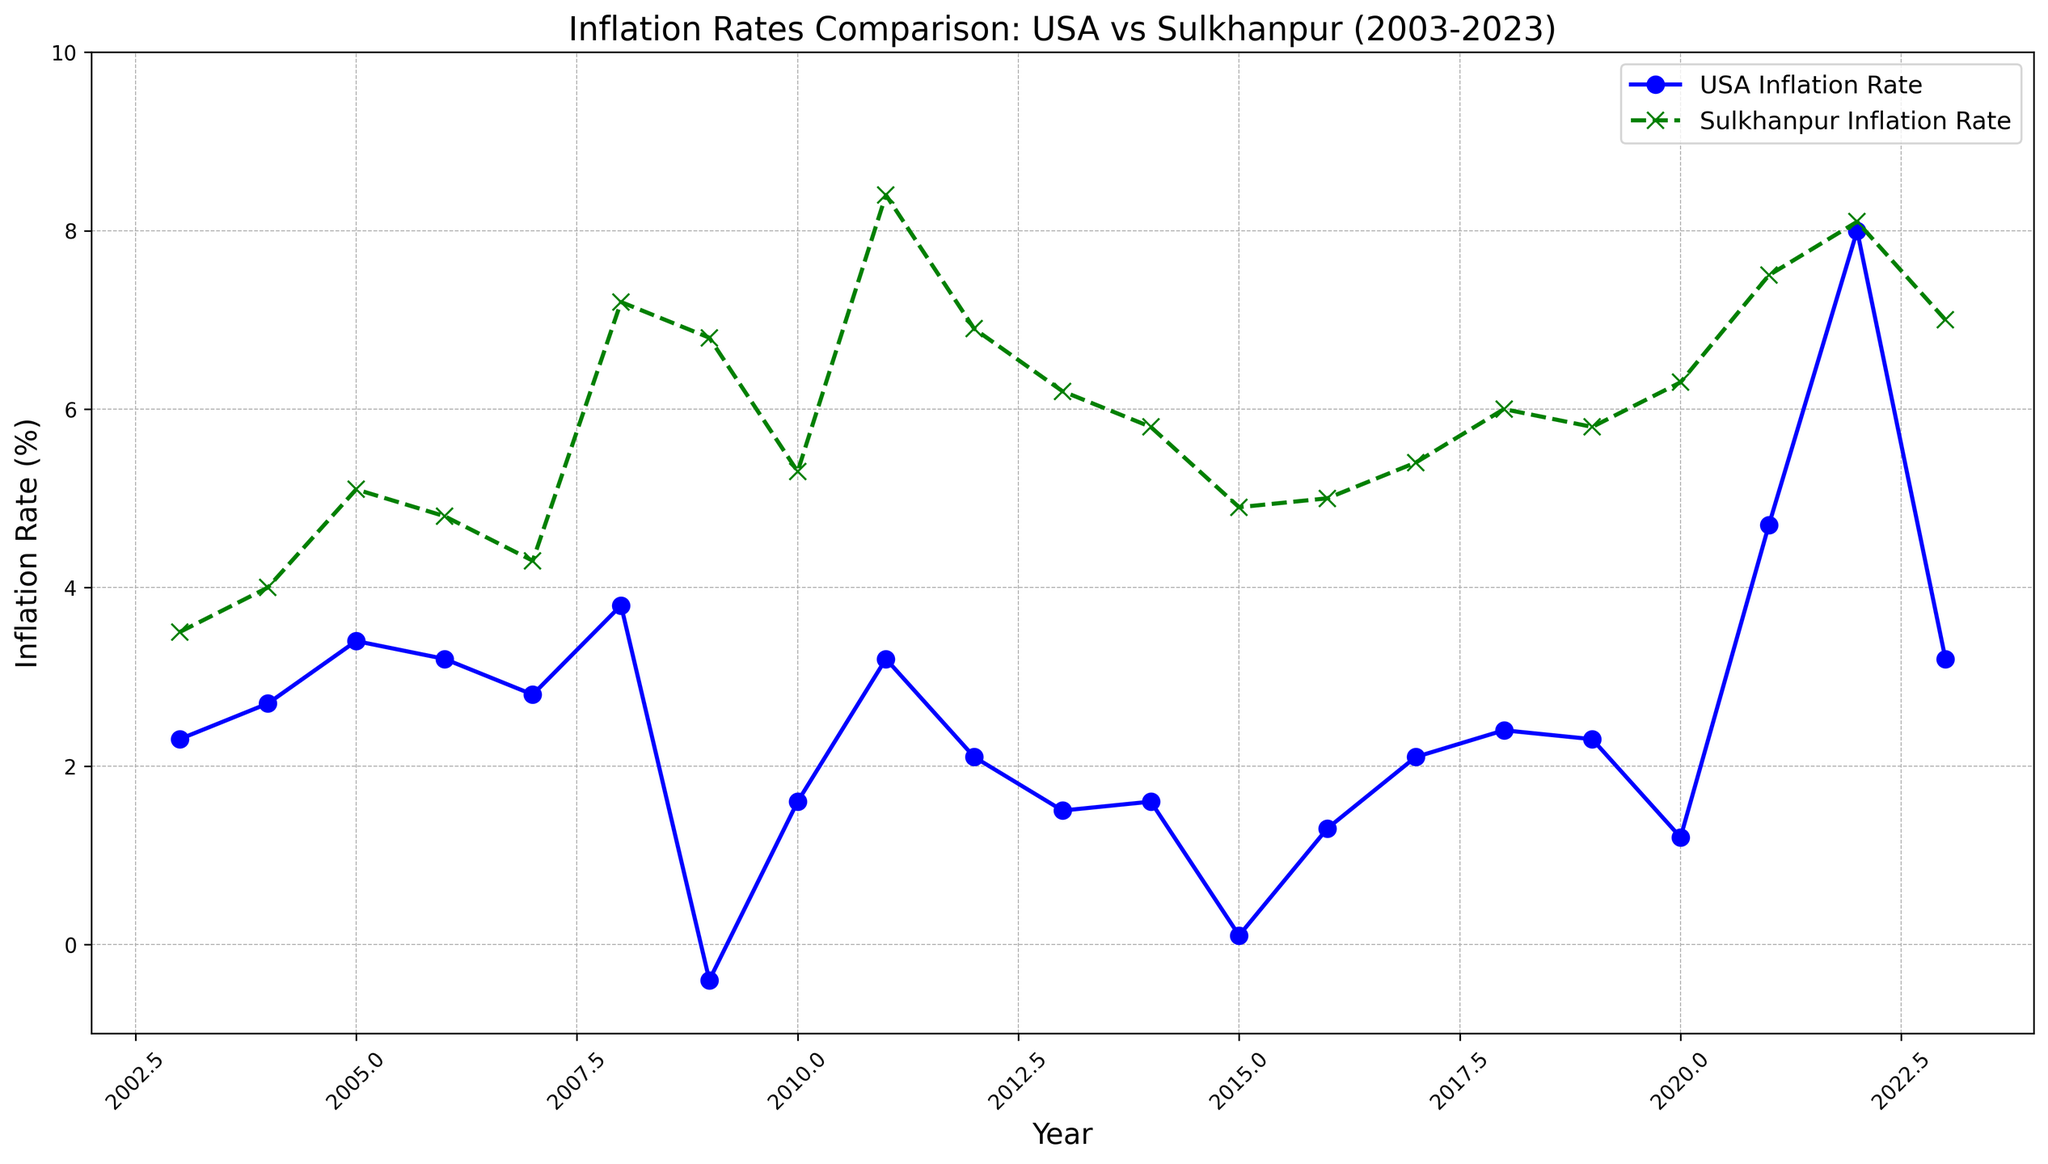Which year did Sulkhanpur experience the highest inflation rate? First, observe the green line representing Sulkhanpur's inflation rate. Identify the year where the line peaks, which is around 2011 with an inflation rate of 8.4%
Answer: 2011 When was the USA's inflation rate lowest, and what was the rate? Look at the blue line representing the USA's inflation rate. The lowest point is around 2009 with an inflation rate of -0.4%
Answer: 2009, -0.4% Which country had a higher inflation rate in 2023? Compare the two points at 2023 for both countries. The USA's inflation rate is lower (3.2%) compared to Sulkhanpur (7.0%)
Answer: Sulkhanpur How many years did the USA experience an inflation rate above 3%? Examine the years where the blue line crosses above the 3% mark: 2005, 2006, 2008, 2011, 2021, and 2022. Count these years
Answer: 6 years Calculate the average inflation rate for Sulkhanpur from 2010 to 2015. Sum the rates for Sulkhanpur from 2010 to 2015: (5.3+8.4+6.9+6.2+5.8+4.9) = 37.5, then divide by 6 years
Answer: 6.25% In which decade did both countries experience their highest inflation rate? Sulkhanpur's highest is in 2011 (8.4%), USA's highest is in 2022 (8.0%). 2011 is in the 2010s and 2022 is in the 2020s.
Answer: 2010s and 2020s In 2008, what was the difference in inflation rate between Sulkhanpur and the USA? Find the rates for both countries in 2008 (Sulkhanpur: 7.2%, USA: 3.8%). Subtract the USA's rate from Sulkhanpur's. 7.2 - 3.8 = 3.4
Answer: 3.4% What is the trend of the USA's inflation rate from 2021 to 2023? Observe the blue line from 2021 (4.7%) through 2023 (3.2%). The rate peaks in 2022 (8.0%) and then drops in 2023.
Answer: Peaked in 2022, then decreased Between 2003 to 2023, which country showed more consistency in their inflation rates? Sulkhanpur's rates fluctuate more significantly (e.g., 7.2% in 2008, 6.8% in 2009, etc.), while the USA's rates are more stable with less drastic changes.
Answer: USA 